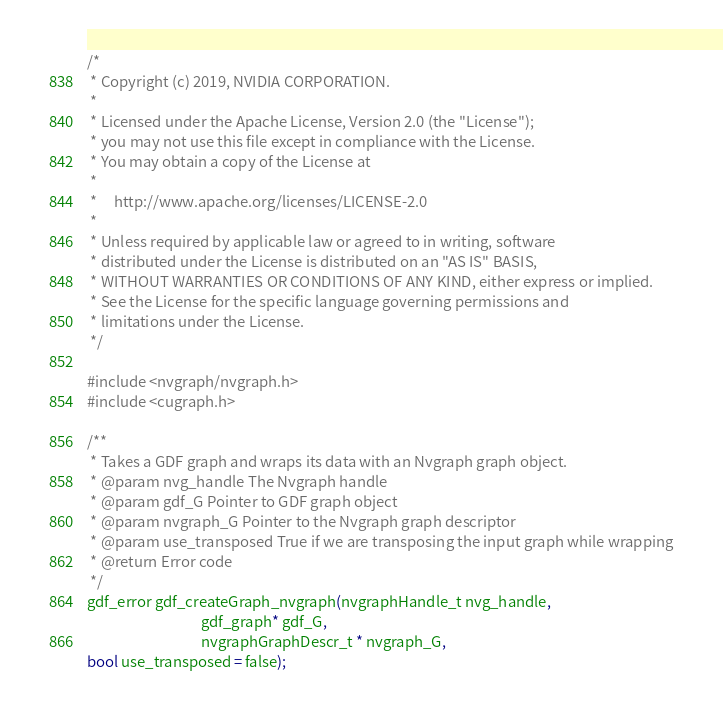Convert code to text. <code><loc_0><loc_0><loc_500><loc_500><_Cuda_>/*
 * Copyright (c) 2019, NVIDIA CORPORATION.
 *
 * Licensed under the Apache License, Version 2.0 (the "License");
 * you may not use this file except in compliance with the License.
 * You may obtain a copy of the License at
 *
 *     http://www.apache.org/licenses/LICENSE-2.0
 *
 * Unless required by applicable law or agreed to in writing, software
 * distributed under the License is distributed on an "AS IS" BASIS,
 * WITHOUT WARRANTIES OR CONDITIONS OF ANY KIND, either express or implied.
 * See the License for the specific language governing permissions and
 * limitations under the License.
 */

#include <nvgraph/nvgraph.h>
#include <cugraph.h>

/**
 * Takes a GDF graph and wraps its data with an Nvgraph graph object.
 * @param nvg_handle The Nvgraph handle
 * @param gdf_G Pointer to GDF graph object
 * @param nvgraph_G Pointer to the Nvgraph graph descriptor
 * @param use_transposed True if we are transposing the input graph while wrapping
 * @return Error code
 */
gdf_error gdf_createGraph_nvgraph(nvgraphHandle_t nvg_handle,
                                  gdf_graph* gdf_G,
                                  nvgraphGraphDescr_t * nvgraph_G,
bool use_transposed = false);
</code> 